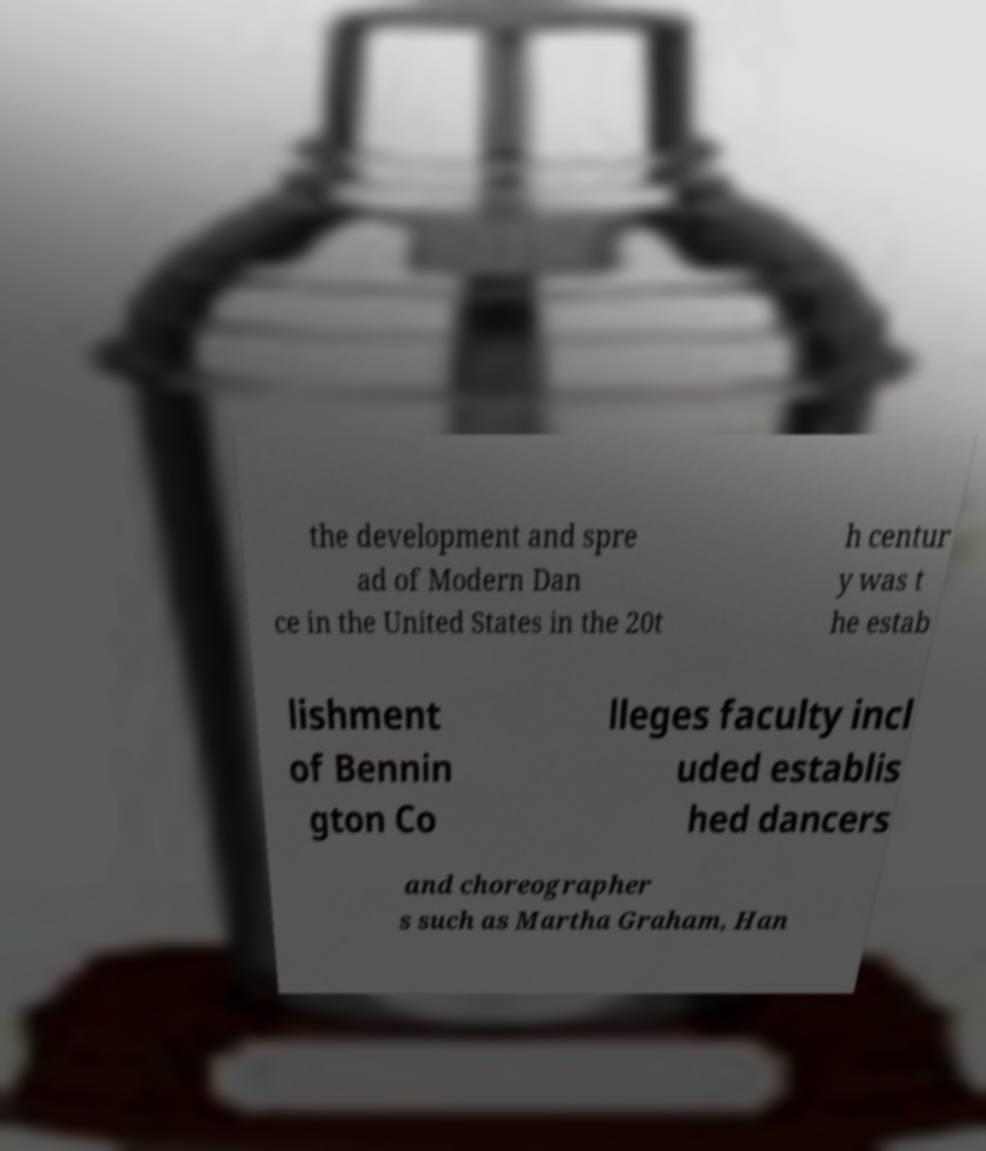Can you accurately transcribe the text from the provided image for me? the development and spre ad of Modern Dan ce in the United States in the 20t h centur y was t he estab lishment of Bennin gton Co lleges faculty incl uded establis hed dancers and choreographer s such as Martha Graham, Han 